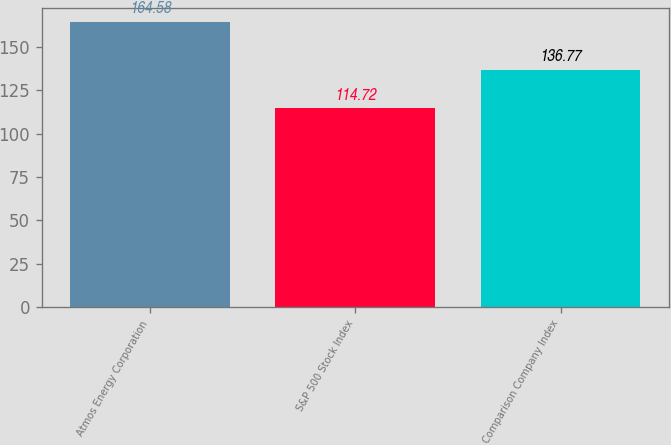<chart> <loc_0><loc_0><loc_500><loc_500><bar_chart><fcel>Atmos Energy Corporation<fcel>S&P 500 Stock Index<fcel>Comparison Company Index<nl><fcel>164.58<fcel>114.72<fcel>136.77<nl></chart> 